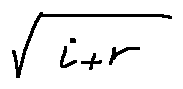Convert formula to latex. <formula><loc_0><loc_0><loc_500><loc_500>\sqrt { i + r }</formula> 